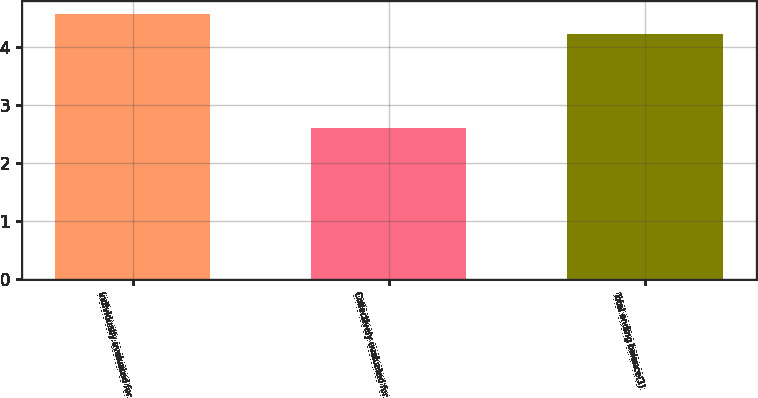<chart> <loc_0><loc_0><loc_500><loc_500><bar_chart><fcel>Individually evaluated for<fcel>Collectively evaluated for<fcel>Total ending balance(1)<nl><fcel>4.57<fcel>2.6<fcel>4.22<nl></chart> 